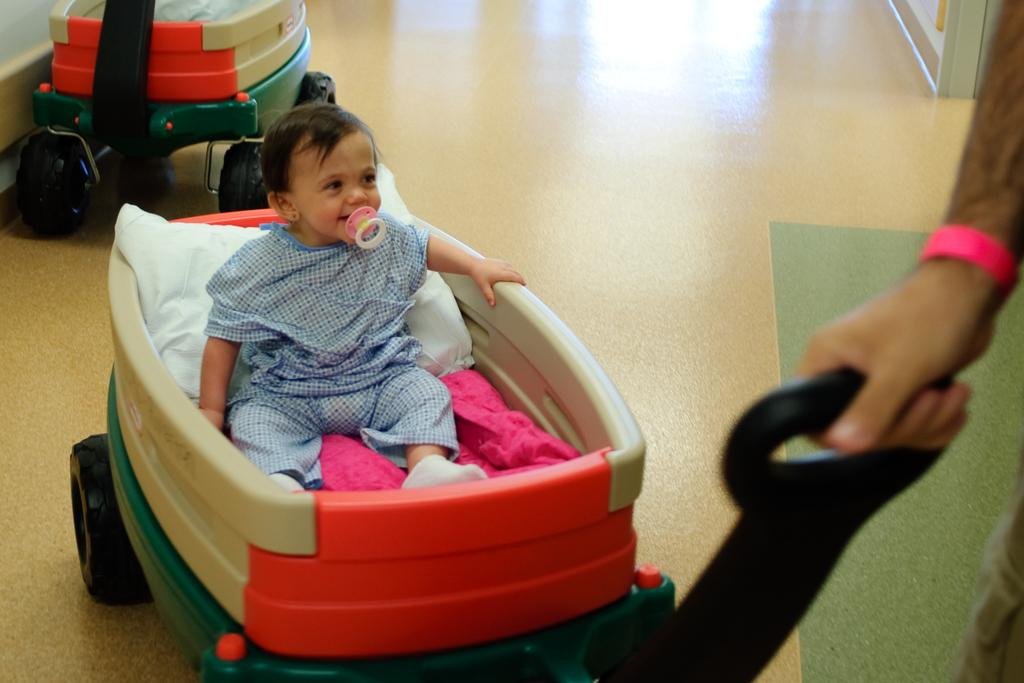How many trolleys are visible in the image? There are two trolleys in the image. What is the person in the image doing with one of the trolleys? A person is holding a trolley. Can you describe the baby's position in the image? There is a baby sitting on a trolley. What is the baby doing in the image? The baby has an object in his mouth. What type of juice is the baby drinking from the zinc container in the image? There is no juice or zinc container present in the image. 